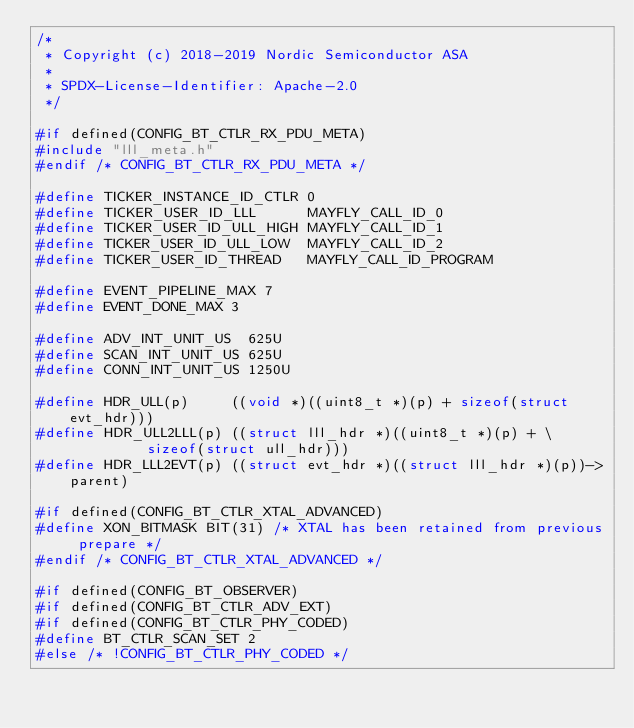Convert code to text. <code><loc_0><loc_0><loc_500><loc_500><_C_>/*
 * Copyright (c) 2018-2019 Nordic Semiconductor ASA
 *
 * SPDX-License-Identifier: Apache-2.0
 */

#if defined(CONFIG_BT_CTLR_RX_PDU_META)
#include "lll_meta.h"
#endif /* CONFIG_BT_CTLR_RX_PDU_META */

#define TICKER_INSTANCE_ID_CTLR 0
#define TICKER_USER_ID_LLL      MAYFLY_CALL_ID_0
#define TICKER_USER_ID_ULL_HIGH MAYFLY_CALL_ID_1
#define TICKER_USER_ID_ULL_LOW  MAYFLY_CALL_ID_2
#define TICKER_USER_ID_THREAD   MAYFLY_CALL_ID_PROGRAM

#define EVENT_PIPELINE_MAX 7
#define EVENT_DONE_MAX 3

#define ADV_INT_UNIT_US  625U
#define SCAN_INT_UNIT_US 625U
#define CONN_INT_UNIT_US 1250U

#define HDR_ULL(p)     ((void *)((uint8_t *)(p) + sizeof(struct evt_hdr)))
#define HDR_ULL2LLL(p) ((struct lll_hdr *)((uint8_t *)(p) + \
					   sizeof(struct ull_hdr)))
#define HDR_LLL2EVT(p) ((struct evt_hdr *)((struct lll_hdr *)(p))->parent)

#if defined(CONFIG_BT_CTLR_XTAL_ADVANCED)
#define XON_BITMASK BIT(31) /* XTAL has been retained from previous prepare */
#endif /* CONFIG_BT_CTLR_XTAL_ADVANCED */

#if defined(CONFIG_BT_OBSERVER)
#if defined(CONFIG_BT_CTLR_ADV_EXT)
#if defined(CONFIG_BT_CTLR_PHY_CODED)
#define BT_CTLR_SCAN_SET 2
#else /* !CONFIG_BT_CTLR_PHY_CODED */</code> 